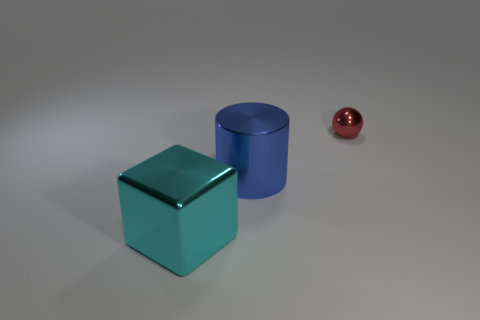Add 3 tiny brown rubber things. How many objects exist? 6 Subtract all balls. How many objects are left? 2 Subtract all small brown metallic balls. Subtract all large things. How many objects are left? 1 Add 1 red balls. How many red balls are left? 2 Add 1 balls. How many balls exist? 2 Subtract 0 gray cylinders. How many objects are left? 3 